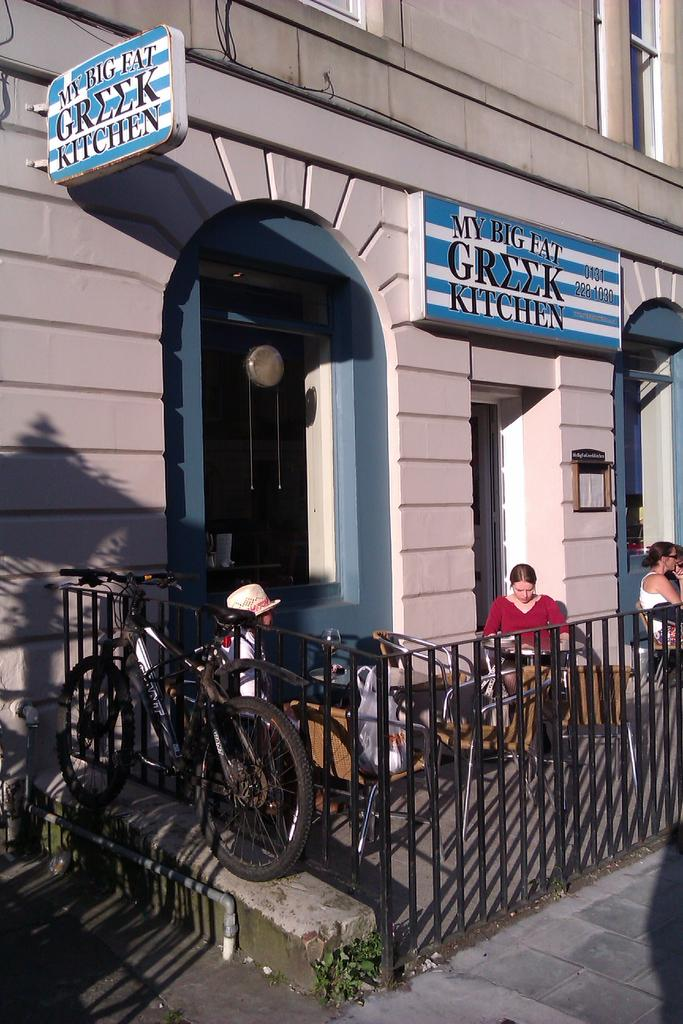What type of structure is visible in the image? There is a building in the image. What feature can be seen on the building? The building has windows. What objects are present in the image besides the building? There are boards, tables, chairs, and a bicycle visible in the image. Are there any people in the image? Yes, there are people in the image. What other architectural feature can be seen in the image? There are grilles in the image. Can you describe the waves crashing on the shore in the image? There are no waves or shore visible in the image; it features a building, people, and various objects. 